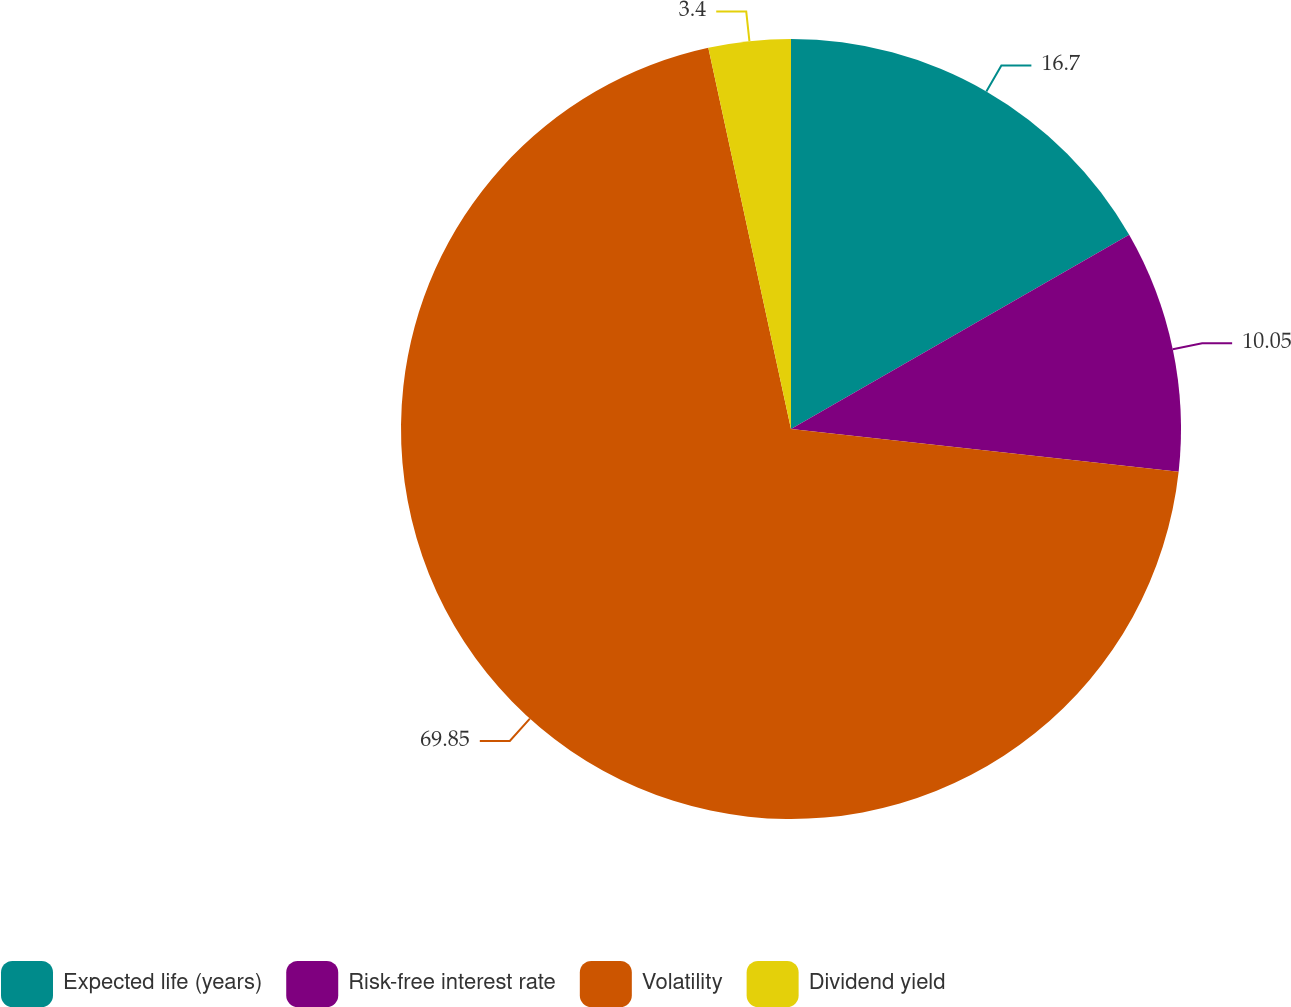Convert chart. <chart><loc_0><loc_0><loc_500><loc_500><pie_chart><fcel>Expected life (years)<fcel>Risk-free interest rate<fcel>Volatility<fcel>Dividend yield<nl><fcel>16.7%<fcel>10.05%<fcel>69.85%<fcel>3.4%<nl></chart> 